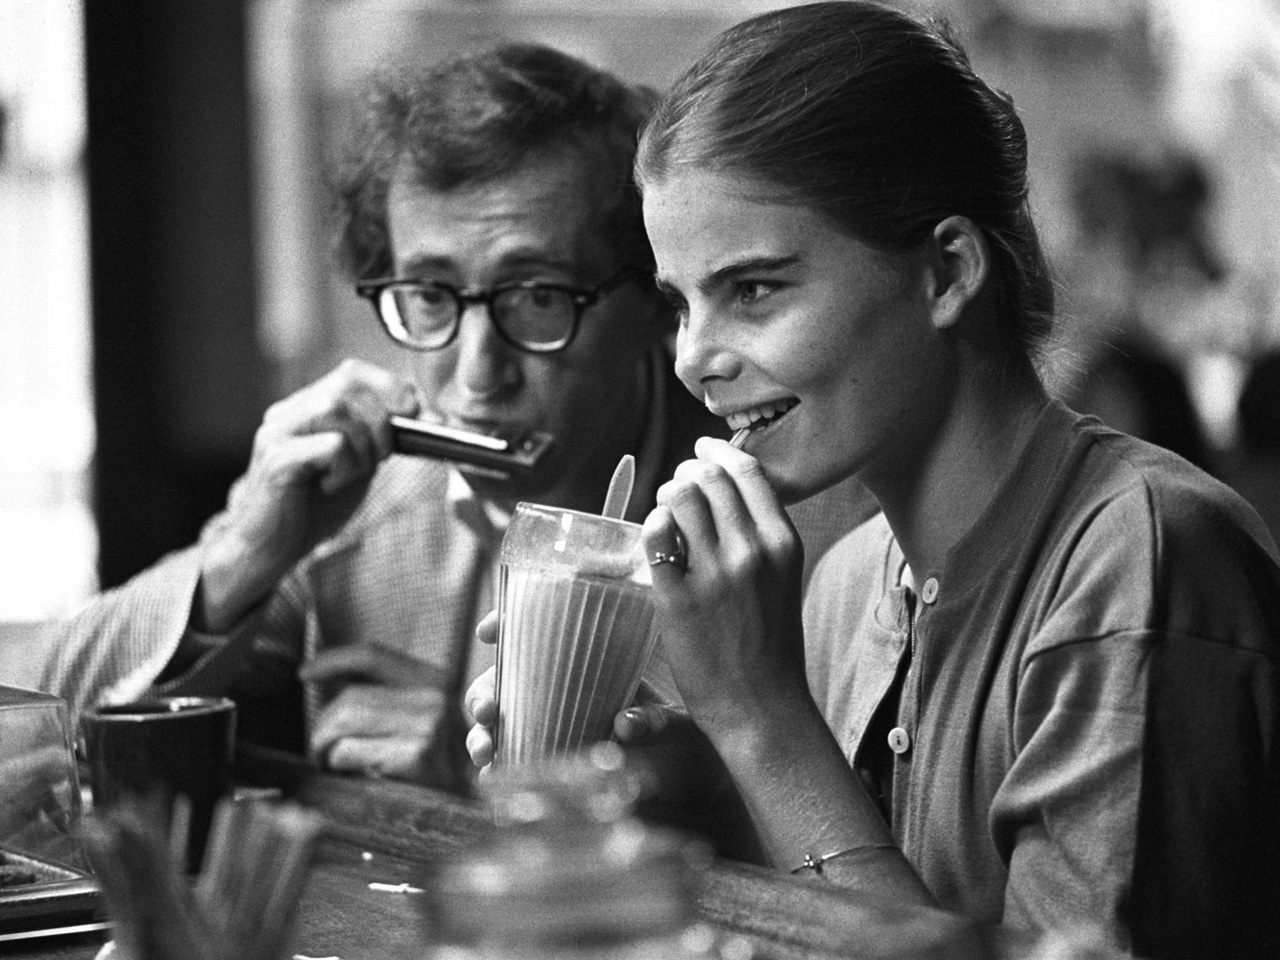What do you think is going on in this snapshot? In this captivating black and white image, we see two individuals sharing a moment at what appears to be a restaurant or cafe. The person on the left, smartly dressed in a suit and glasses, is deeply engrossed in playing a harmonica, adding a musical touch to the atmosphere. Meanwhile, the person on the right, casually dressed in a collared shirt, is enjoying a drink through a straw, her face radiating contentment. The blurred background, featuring other patrons and objects, shifts the entire focus to this evocative interaction, evoking a sense of intimacy and artistry. 